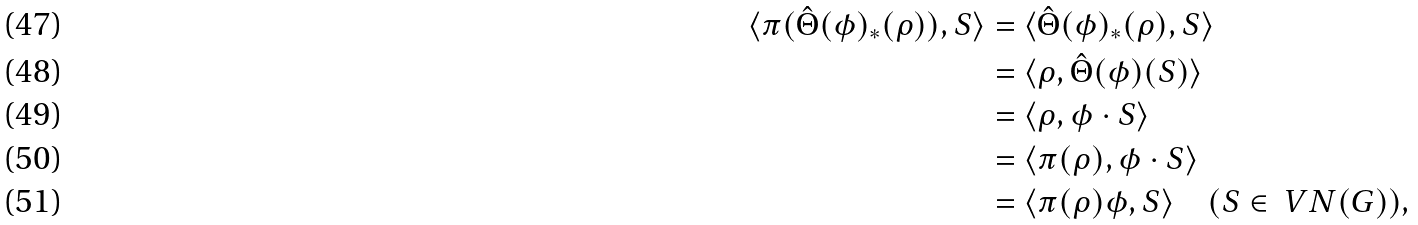<formula> <loc_0><loc_0><loc_500><loc_500>\langle \pi ( \hat { \Theta } ( \phi ) _ { \ast } ( \rho ) ) , S \rangle & = \langle \hat { \Theta } ( \phi ) _ { \ast } ( \rho ) , S \rangle \\ & = \langle \rho , \hat { \Theta } ( \phi ) ( S ) \rangle \\ & = \langle \rho , \phi \cdot S \rangle \\ & = \langle \pi ( \rho ) , \phi \cdot S \rangle \\ & = \langle \pi ( \rho ) \phi , S \rangle \quad ( S \in \ V N ( G ) ) ,</formula> 